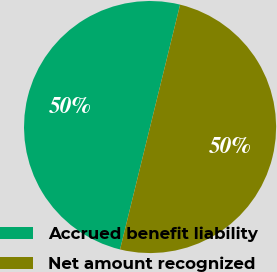Convert chart to OTSL. <chart><loc_0><loc_0><loc_500><loc_500><pie_chart><fcel>Accrued benefit liability<fcel>Net amount recognized<nl><fcel>50.0%<fcel>50.0%<nl></chart> 